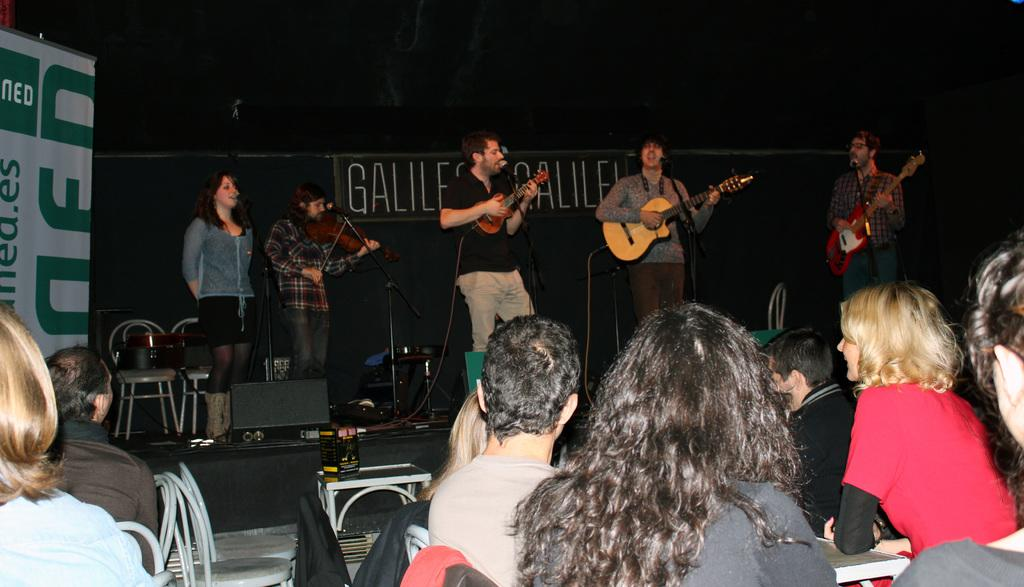What are the people in the image doing? There is a group of people playing musical instruments in the image. Can you describe the seating arrangement of the people in the image? There is a group of people sitting on chairs in the image. What object is present in the image that is commonly used for amplifying sound? There is a microphone (mic) in the image. What can be seen on the wall or background in the image? There is a poster in the image. How many arms are visible in the image? The number of arms visible in the image cannot be determined from the provided facts, as they do not mention the number of people or their body parts. 